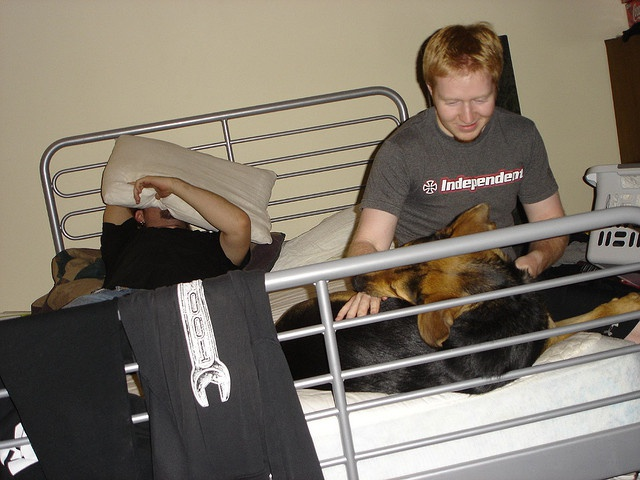Describe the objects in this image and their specific colors. I can see dog in tan, black, darkgray, and maroon tones, people in tan, gray, maroon, and black tones, bed in tan, white, darkgray, and gray tones, and people in tan, black, gray, brown, and maroon tones in this image. 